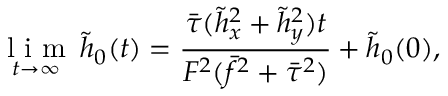Convert formula to latex. <formula><loc_0><loc_0><loc_500><loc_500>\underset { t \rightarrow \infty } { l i m } \, \tilde { h } _ { 0 } ( t ) = \frac { \bar { \tau } ( \tilde { h } _ { x } ^ { 2 } + \tilde { h } _ { y } ^ { 2 } ) t } { F ^ { 2 } ( \bar { f } ^ { 2 } + \bar { \tau } ^ { 2 } ) } + \tilde { h } _ { 0 } ( 0 ) ,</formula> 